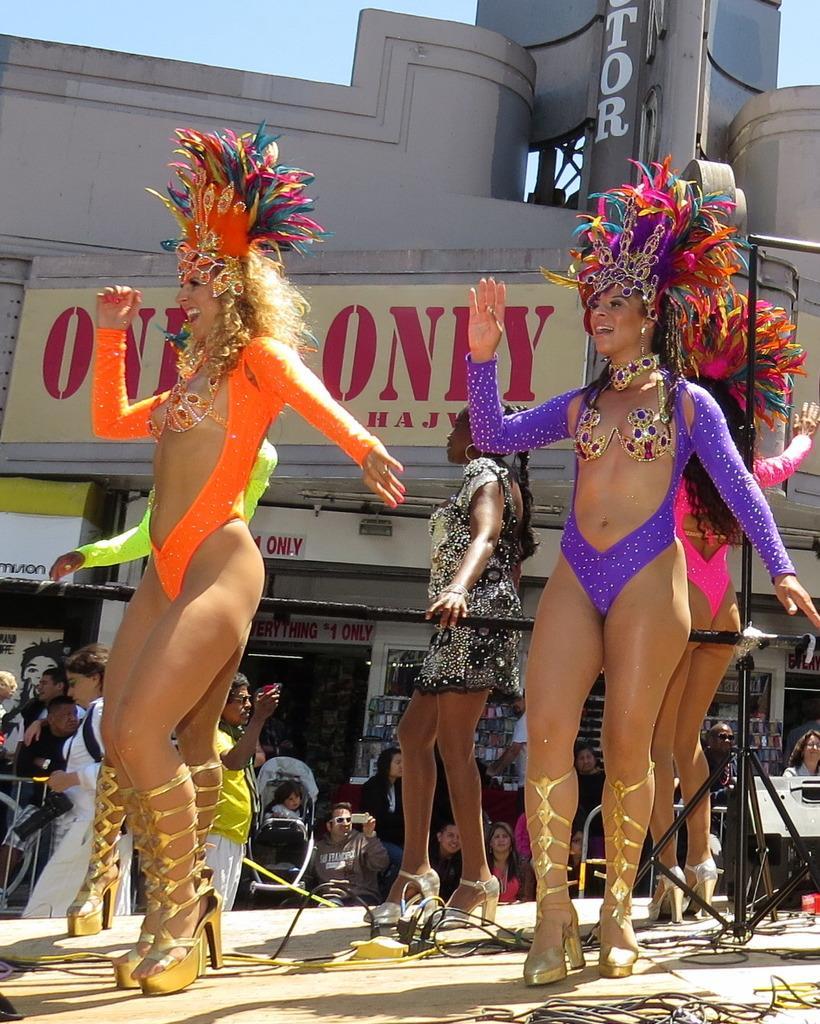In one or two sentences, can you explain what this image depicts? In the image there are a group of women performing some activity, they are wearing different costumes and around those women there are many other people, in the background there are some stores. 